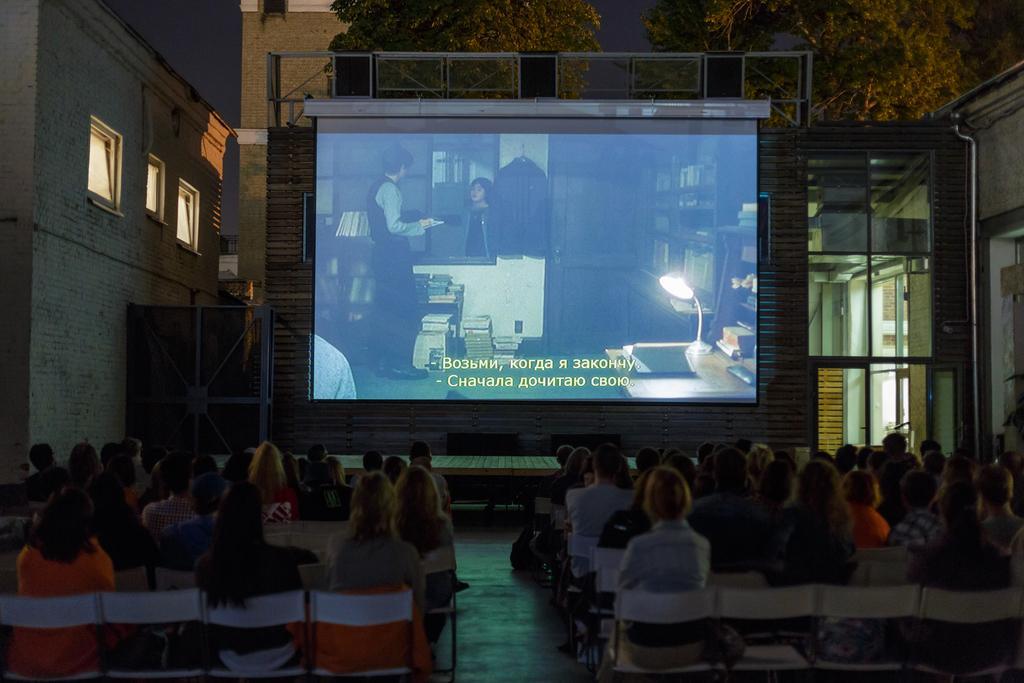In one or two sentences, can you explain what this image depicts? At the bottom of the picture, we see many people are sitting on the chairs. All of them are watching the movie. In the background, we see a projector screen on which movie is displayed. Behind that, we see a wall and there are trees. On the right side, we see a glass door. On the left side, we see a wall and the ventilators. 